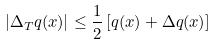<formula> <loc_0><loc_0><loc_500><loc_500>| \Delta _ { T } q ( x ) | \leq \frac { 1 } { 2 } \, [ q ( x ) + \Delta q ( x ) ]</formula> 